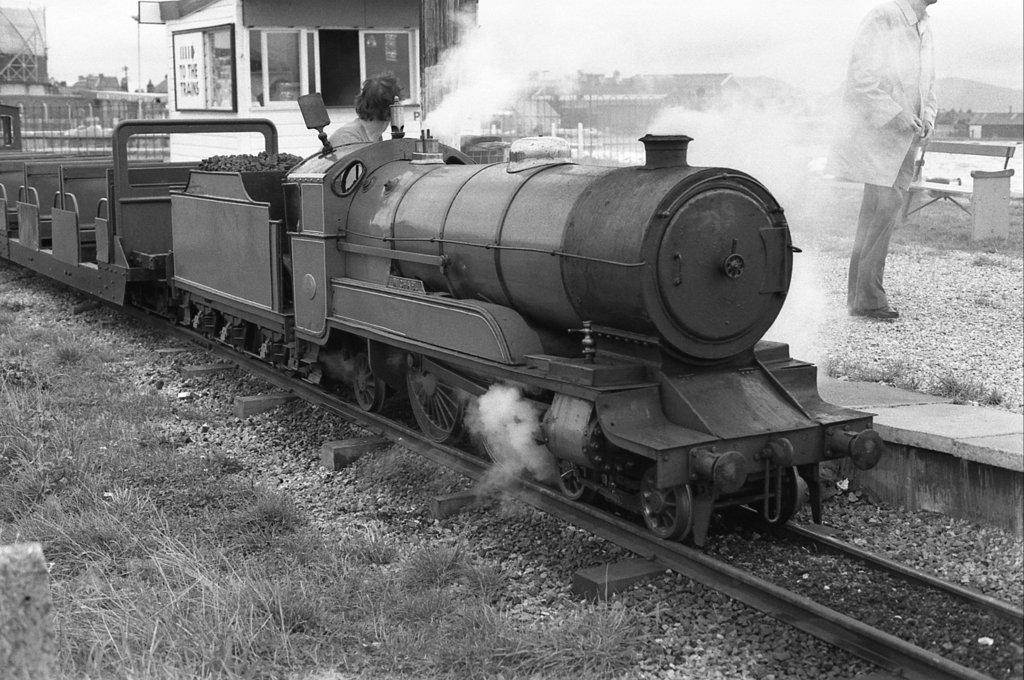This is goods train?
Offer a very short reply. Unanswerable. 